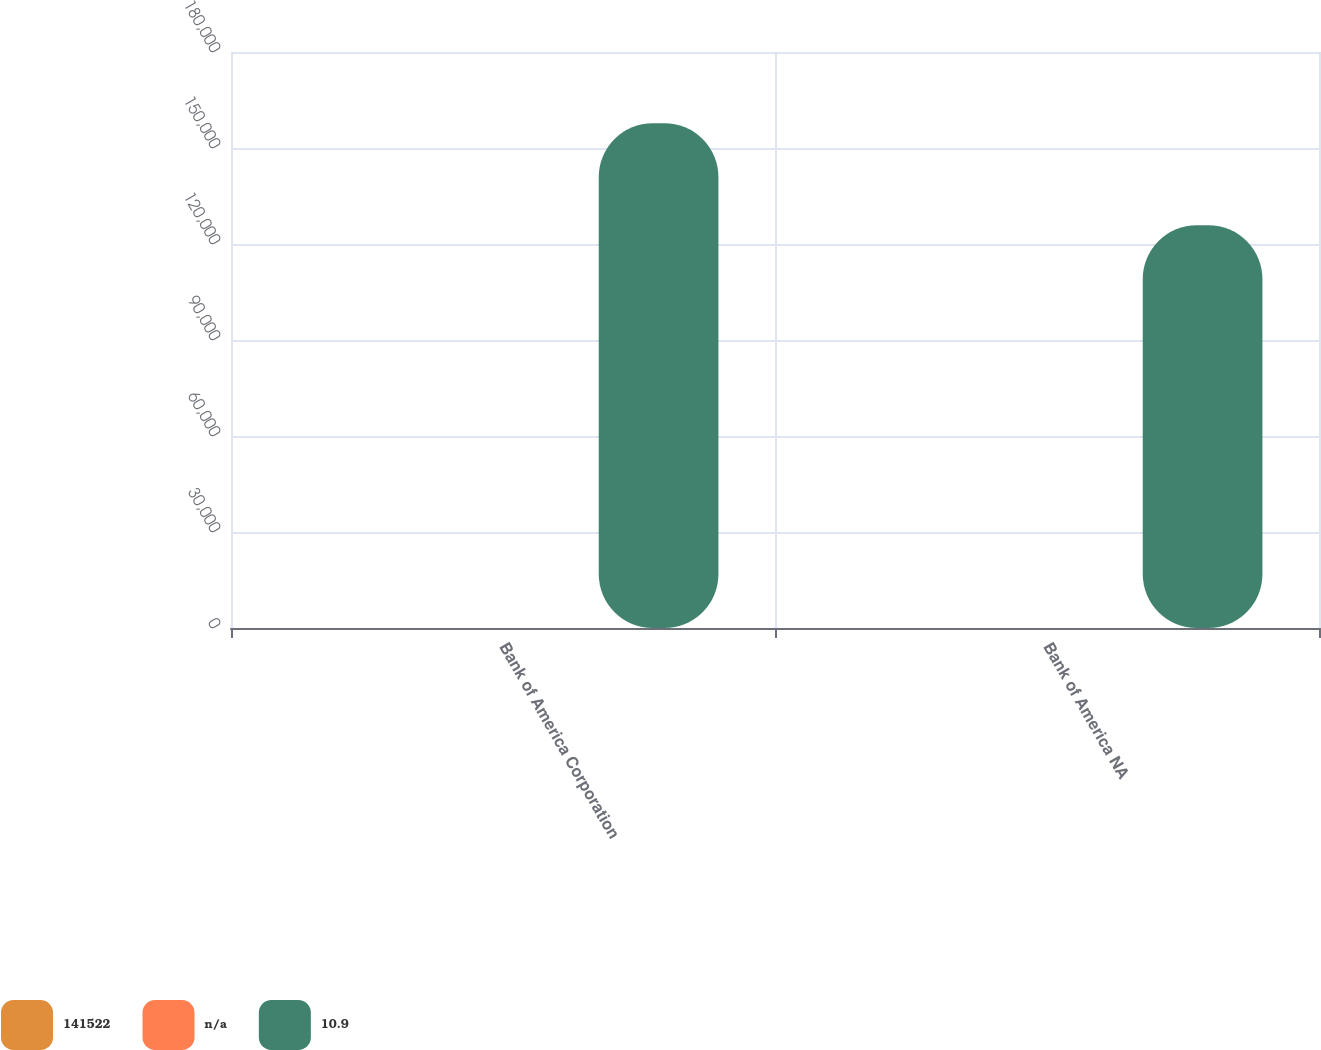<chart> <loc_0><loc_0><loc_500><loc_500><stacked_bar_chart><ecel><fcel>Bank of America Corporation<fcel>Bank of America NA<nl><fcel>141522<fcel>13.4<fcel>13.1<nl><fcel>nan<fcel>12.2<fcel>12.3<nl><fcel>10.9<fcel>157742<fcel>125886<nl></chart> 